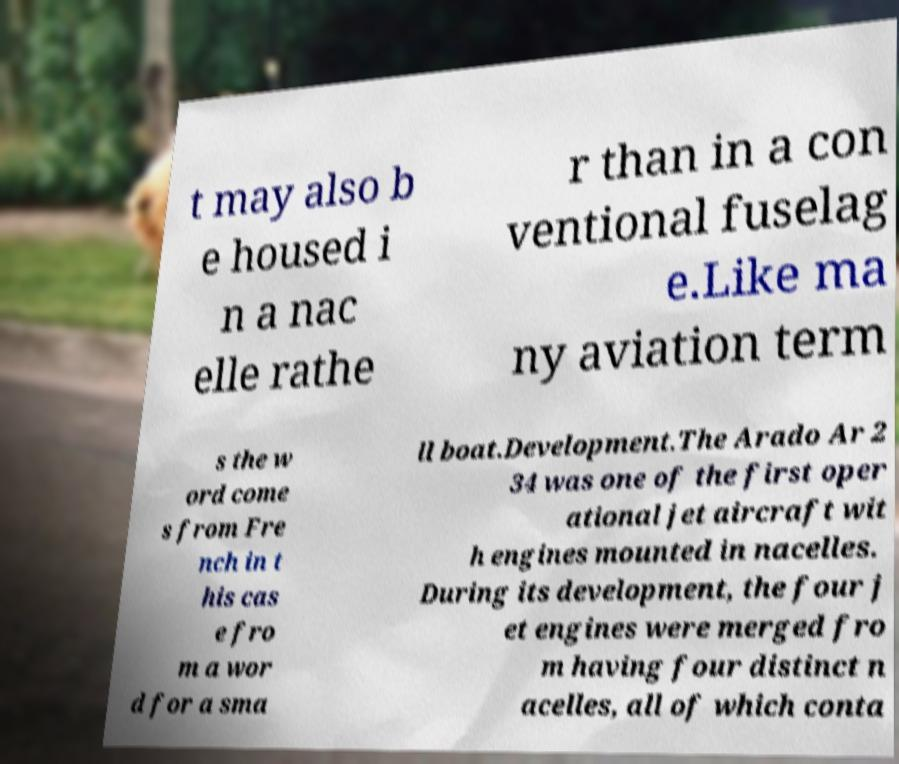For documentation purposes, I need the text within this image transcribed. Could you provide that? t may also b e housed i n a nac elle rathe r than in a con ventional fuselag e.Like ma ny aviation term s the w ord come s from Fre nch in t his cas e fro m a wor d for a sma ll boat.Development.The Arado Ar 2 34 was one of the first oper ational jet aircraft wit h engines mounted in nacelles. During its development, the four j et engines were merged fro m having four distinct n acelles, all of which conta 